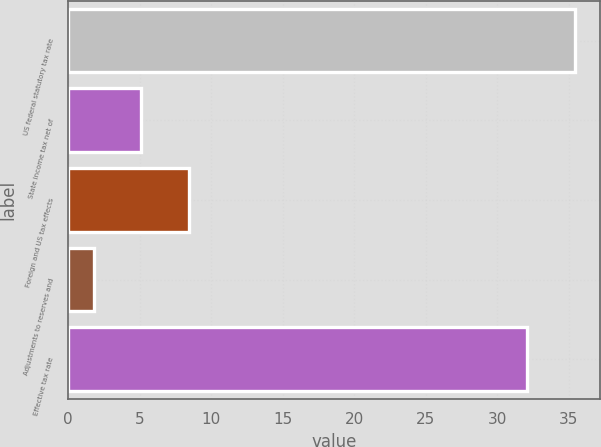Convert chart. <chart><loc_0><loc_0><loc_500><loc_500><bar_chart><fcel>US federal statutory tax rate<fcel>State income tax net of<fcel>Foreign and US tax effects<fcel>Adjustments to reserves and<fcel>Effective tax rate<nl><fcel>35.42<fcel>5.12<fcel>8.44<fcel>1.8<fcel>32.1<nl></chart> 